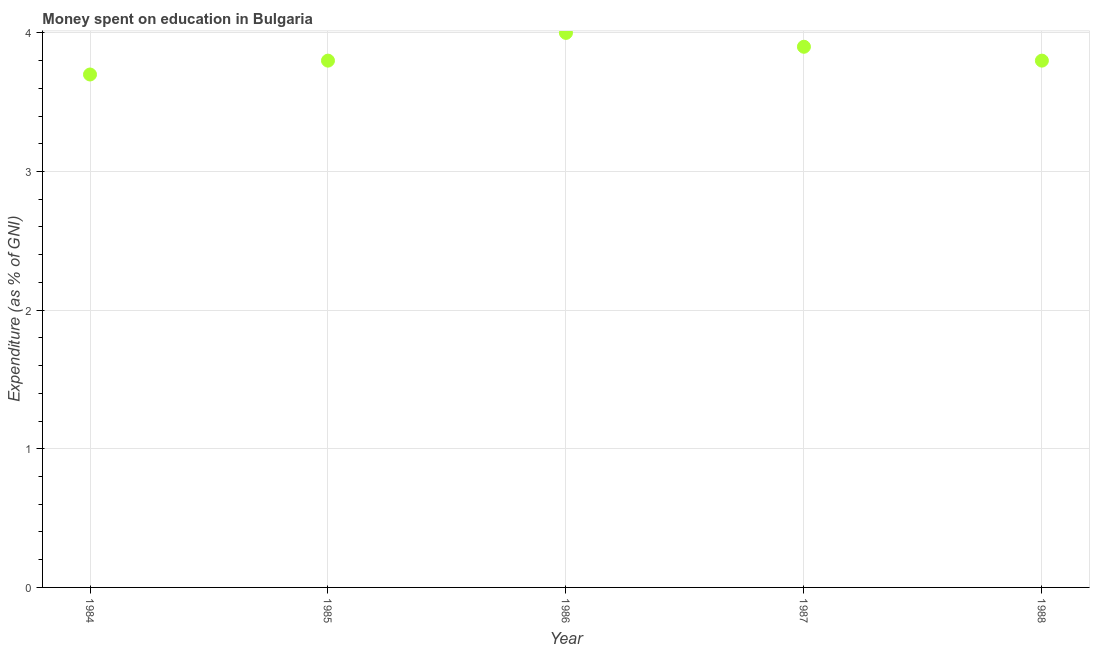What is the expenditure on education in 1984?
Keep it short and to the point. 3.7. Across all years, what is the maximum expenditure on education?
Your answer should be compact. 4. Across all years, what is the minimum expenditure on education?
Offer a very short reply. 3.7. In which year was the expenditure on education maximum?
Provide a succinct answer. 1986. What is the difference between the expenditure on education in 1984 and 1987?
Offer a terse response. -0.2. What is the average expenditure on education per year?
Provide a short and direct response. 3.84. What is the median expenditure on education?
Offer a terse response. 3.8. In how many years, is the expenditure on education greater than 1.2 %?
Give a very brief answer. 5. Do a majority of the years between 1987 and 1986 (inclusive) have expenditure on education greater than 3.4 %?
Provide a short and direct response. No. What is the ratio of the expenditure on education in 1985 to that in 1987?
Provide a short and direct response. 0.97. Is the expenditure on education in 1984 less than that in 1987?
Offer a very short reply. Yes. Is the difference between the expenditure on education in 1987 and 1988 greater than the difference between any two years?
Give a very brief answer. No. What is the difference between the highest and the second highest expenditure on education?
Provide a short and direct response. 0.1. Is the sum of the expenditure on education in 1986 and 1988 greater than the maximum expenditure on education across all years?
Keep it short and to the point. Yes. What is the difference between the highest and the lowest expenditure on education?
Provide a short and direct response. 0.3. In how many years, is the expenditure on education greater than the average expenditure on education taken over all years?
Give a very brief answer. 2. How many dotlines are there?
Your answer should be very brief. 1. Are the values on the major ticks of Y-axis written in scientific E-notation?
Provide a succinct answer. No. Does the graph contain grids?
Your answer should be very brief. Yes. What is the title of the graph?
Keep it short and to the point. Money spent on education in Bulgaria. What is the label or title of the Y-axis?
Provide a short and direct response. Expenditure (as % of GNI). What is the Expenditure (as % of GNI) in 1984?
Make the answer very short. 3.7. What is the Expenditure (as % of GNI) in 1987?
Your response must be concise. 3.9. What is the difference between the Expenditure (as % of GNI) in 1984 and 1986?
Offer a very short reply. -0.3. What is the difference between the Expenditure (as % of GNI) in 1987 and 1988?
Your answer should be compact. 0.1. What is the ratio of the Expenditure (as % of GNI) in 1984 to that in 1985?
Ensure brevity in your answer.  0.97. What is the ratio of the Expenditure (as % of GNI) in 1984 to that in 1986?
Give a very brief answer. 0.93. What is the ratio of the Expenditure (as % of GNI) in 1984 to that in 1987?
Your answer should be compact. 0.95. What is the ratio of the Expenditure (as % of GNI) in 1984 to that in 1988?
Provide a succinct answer. 0.97. What is the ratio of the Expenditure (as % of GNI) in 1985 to that in 1987?
Make the answer very short. 0.97. What is the ratio of the Expenditure (as % of GNI) in 1985 to that in 1988?
Ensure brevity in your answer.  1. What is the ratio of the Expenditure (as % of GNI) in 1986 to that in 1988?
Provide a succinct answer. 1.05. 